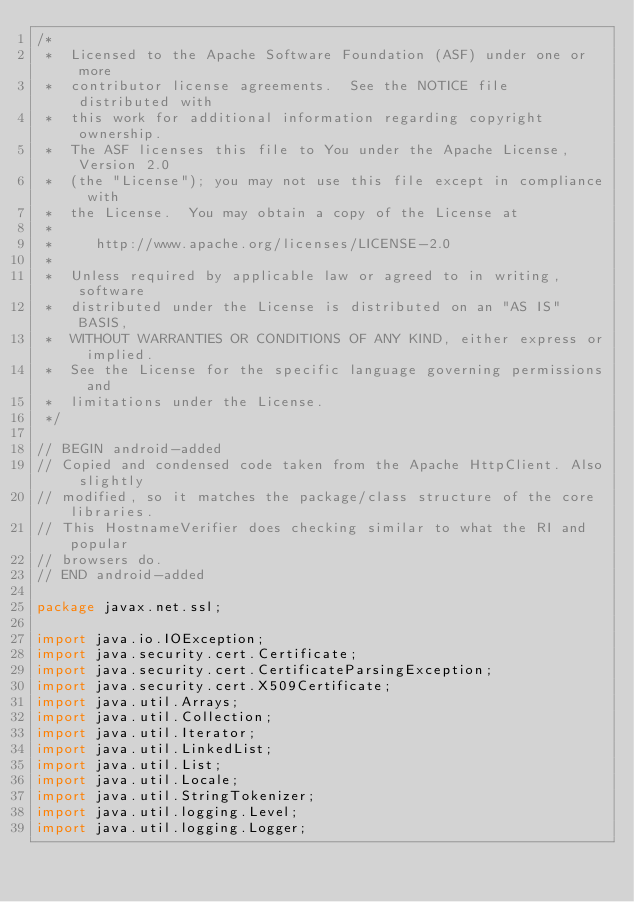Convert code to text. <code><loc_0><loc_0><loc_500><loc_500><_Java_>/*
 *  Licensed to the Apache Software Foundation (ASF) under one or more
 *  contributor license agreements.  See the NOTICE file distributed with
 *  this work for additional information regarding copyright ownership.
 *  The ASF licenses this file to You under the Apache License, Version 2.0
 *  (the "License"); you may not use this file except in compliance with
 *  the License.  You may obtain a copy of the License at
 *
 *     http://www.apache.org/licenses/LICENSE-2.0
 *
 *  Unless required by applicable law or agreed to in writing, software
 *  distributed under the License is distributed on an "AS IS" BASIS,
 *  WITHOUT WARRANTIES OR CONDITIONS OF ANY KIND, either express or implied.
 *  See the License for the specific language governing permissions and
 *  limitations under the License.
 */

// BEGIN android-added
// Copied and condensed code taken from the Apache HttpClient. Also slightly
// modified, so it matches the package/class structure of the core libraries.
// This HostnameVerifier does checking similar to what the RI and popular
// browsers do.
// END android-added

package javax.net.ssl;

import java.io.IOException;
import java.security.cert.Certificate;
import java.security.cert.CertificateParsingException;
import java.security.cert.X509Certificate;
import java.util.Arrays;
import java.util.Collection;
import java.util.Iterator;
import java.util.LinkedList;
import java.util.List;
import java.util.Locale;
import java.util.StringTokenizer;
import java.util.logging.Level;
import java.util.logging.Logger;</code> 